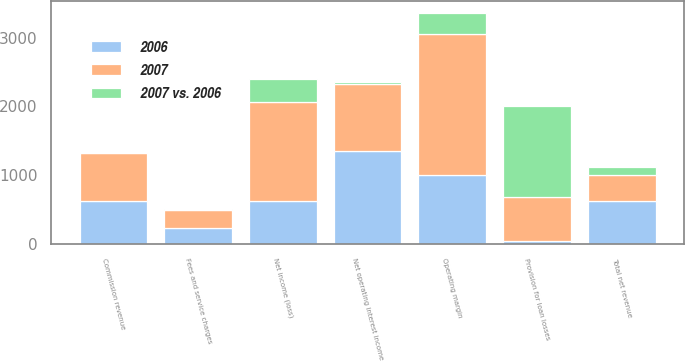Convert chart. <chart><loc_0><loc_0><loc_500><loc_500><stacked_bar_chart><ecel><fcel>Total net revenue<fcel>Net operating interest income<fcel>Provision for loan losses<fcel>Commission revenue<fcel>Fees and service charges<fcel>Operating margin<fcel>Net income (loss)<nl><fcel>2007<fcel>378.2<fcel>969<fcel>640.1<fcel>694.1<fcel>258.1<fcel>2054.6<fcel>1441.8<nl><fcel>2006<fcel>625.3<fcel>1355.1<fcel>45<fcel>625.3<fcel>238.8<fcel>1000.8<fcel>628.9<nl><fcel>2007 vs. 2006<fcel>116<fcel>28<fcel>1323<fcel>11<fcel>8<fcel>305<fcel>329<nl></chart> 